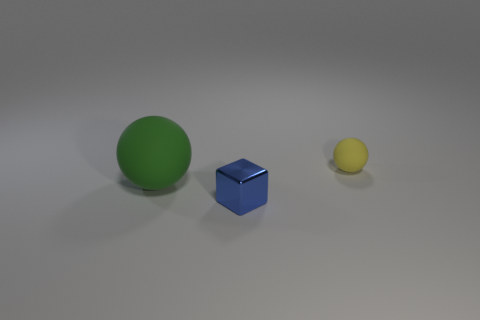Add 3 big green spheres. How many objects exist? 6 Subtract all blocks. How many objects are left? 2 Subtract all small spheres. Subtract all tiny rubber spheres. How many objects are left? 1 Add 1 blue things. How many blue things are left? 2 Add 2 metal balls. How many metal balls exist? 2 Subtract 1 yellow spheres. How many objects are left? 2 